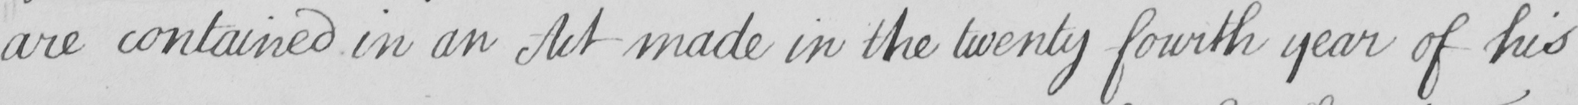Please provide the text content of this handwritten line. are contained in an Act made in the twenty fourth year of his 